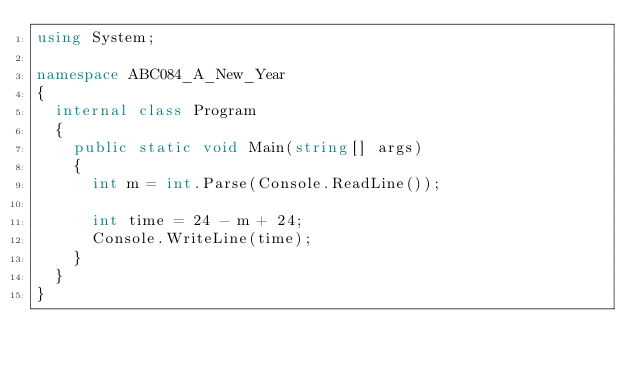Convert code to text. <code><loc_0><loc_0><loc_500><loc_500><_C#_>using System;

namespace ABC084_A_New_Year
{
	internal class Program
	{
		public static void Main(string[] args)
		{
			int m = int.Parse(Console.ReadLine());

			int time = 24 - m + 24;
			Console.WriteLine(time);
		}
	}
}</code> 